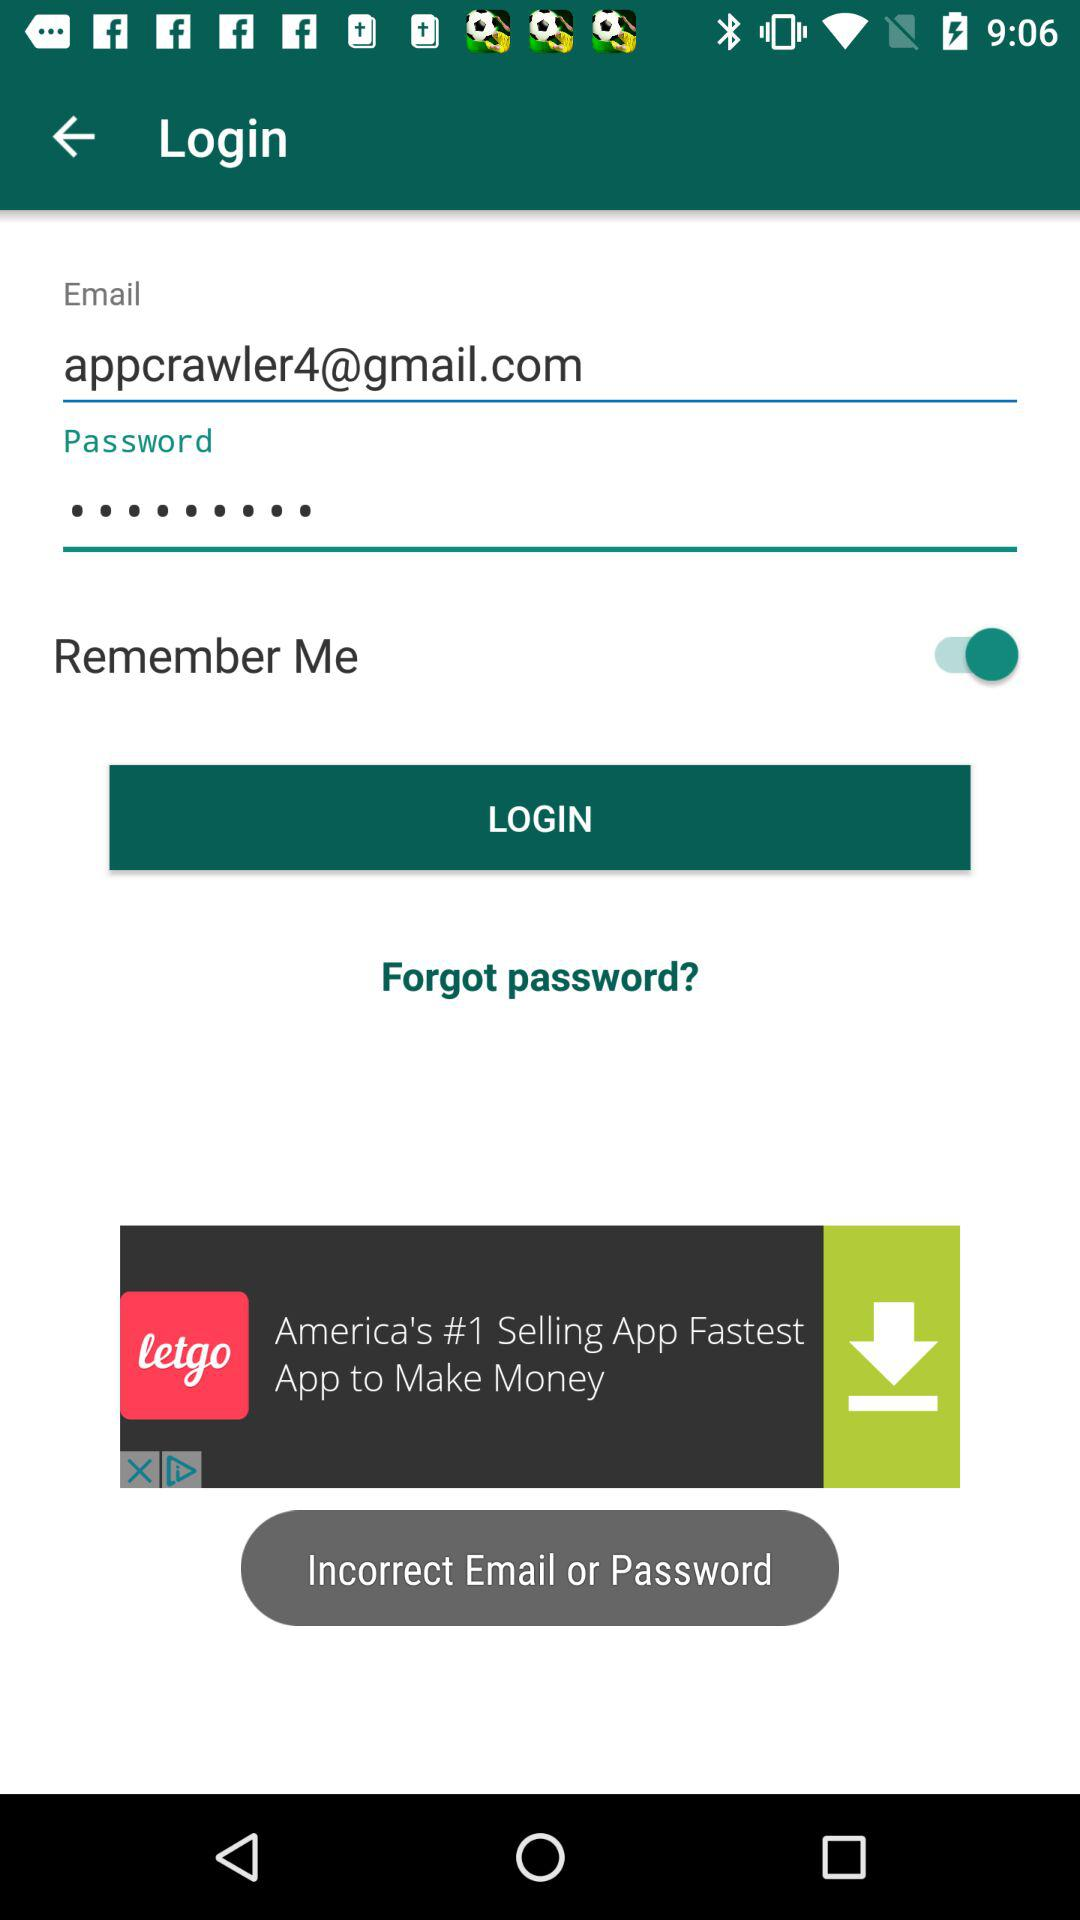What is the status of "Remember Me? The status is "on". 